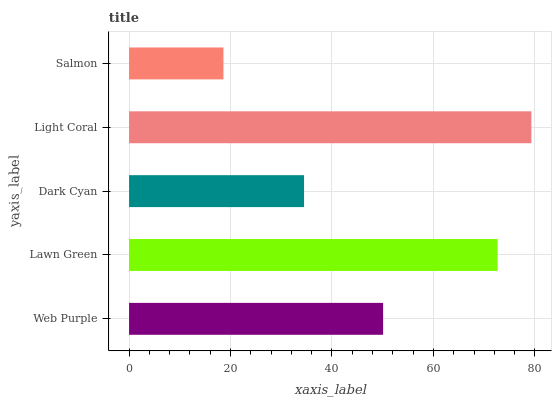Is Salmon the minimum?
Answer yes or no. Yes. Is Light Coral the maximum?
Answer yes or no. Yes. Is Lawn Green the minimum?
Answer yes or no. No. Is Lawn Green the maximum?
Answer yes or no. No. Is Lawn Green greater than Web Purple?
Answer yes or no. Yes. Is Web Purple less than Lawn Green?
Answer yes or no. Yes. Is Web Purple greater than Lawn Green?
Answer yes or no. No. Is Lawn Green less than Web Purple?
Answer yes or no. No. Is Web Purple the high median?
Answer yes or no. Yes. Is Web Purple the low median?
Answer yes or no. Yes. Is Light Coral the high median?
Answer yes or no. No. Is Salmon the low median?
Answer yes or no. No. 